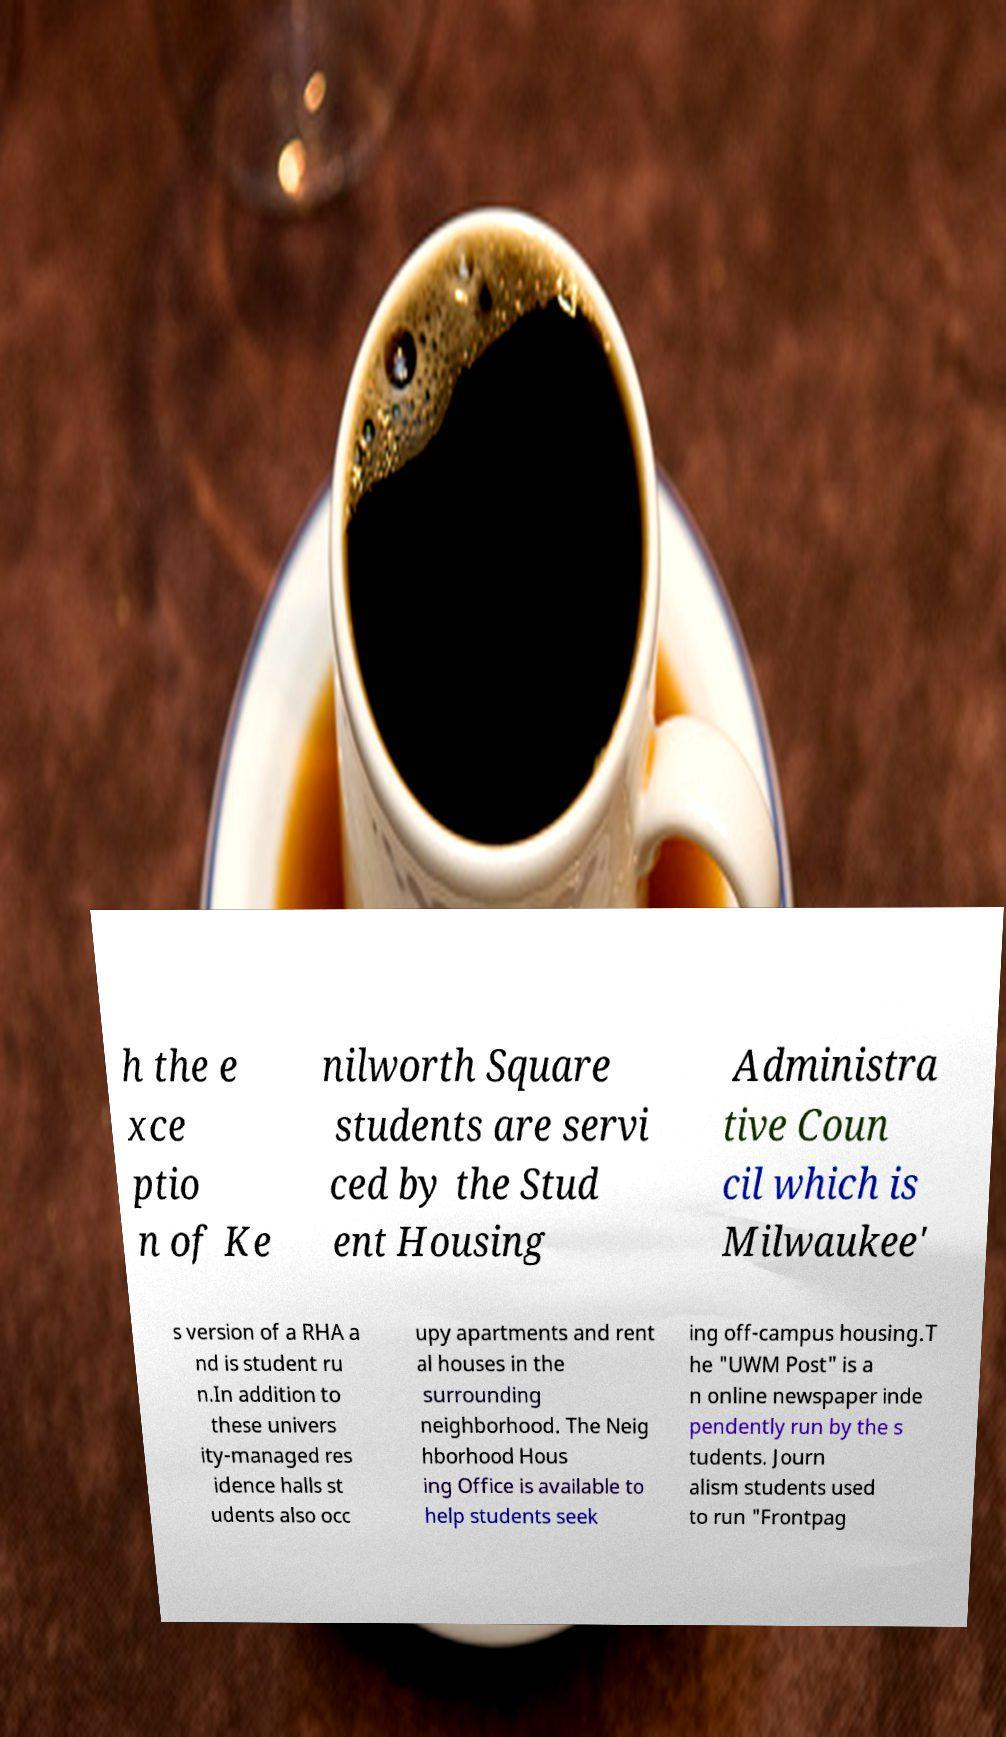Could you extract and type out the text from this image? h the e xce ptio n of Ke nilworth Square students are servi ced by the Stud ent Housing Administra tive Coun cil which is Milwaukee' s version of a RHA a nd is student ru n.In addition to these univers ity-managed res idence halls st udents also occ upy apartments and rent al houses in the surrounding neighborhood. The Neig hborhood Hous ing Office is available to help students seek ing off-campus housing.T he "UWM Post" is a n online newspaper inde pendently run by the s tudents. Journ alism students used to run "Frontpag 